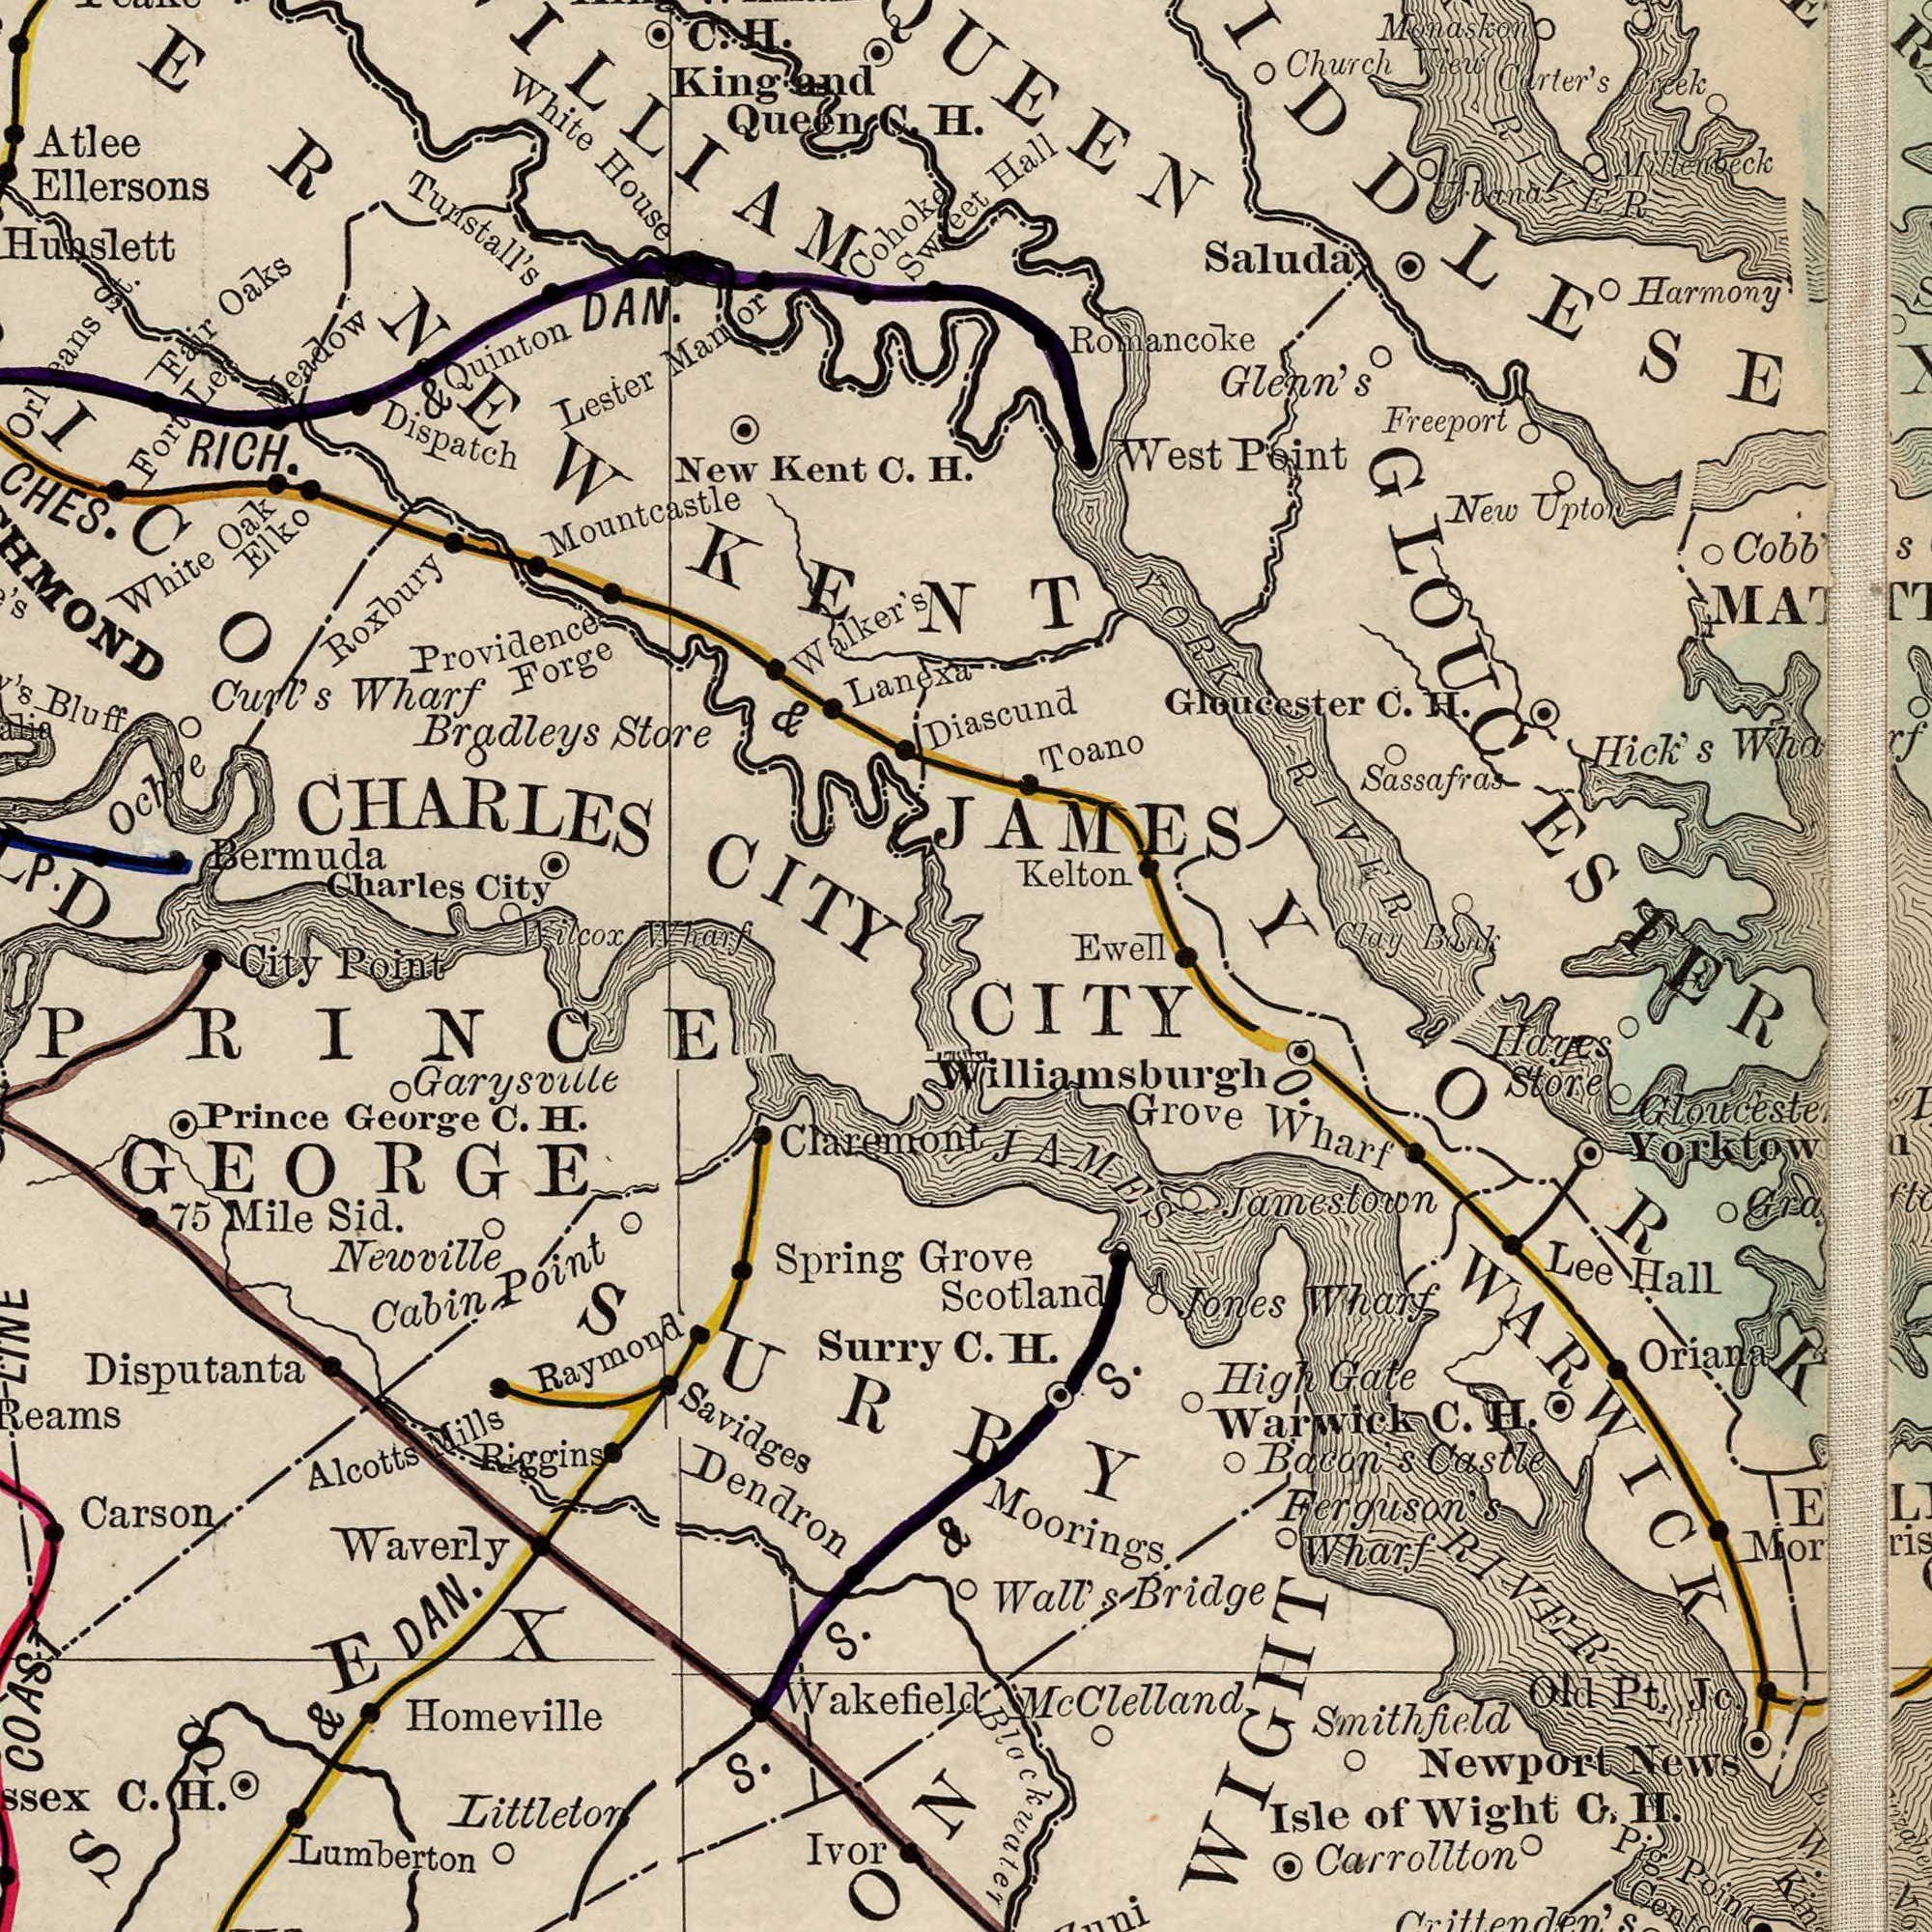What text is visible in the upper-left corner? Tunstall's Charles City Bermuda Providence Forge Atlee RICH. & DAN. White House Ellersons Mountcastle New Kent C. H. Bluff Ochre Fair Oāks Lester Manor Bradleys Store Wilcox Wharf Elko Walker's D Dispatch Curl's Wharf CHARLES CITY Lanexa White Oak Meadow Roxbury Quinton Sweet Fort Lee Cohoke King and Queen C. H eans St. City Point & C. H. ###ICO What text can you see in the bottom-right section? CITY C. H. Grove S. Carrollton Yorktown Grove Wharf Smithfield Jamestown Newport News Oriana Scotland Hayes Store Bacon's Castle High Gate Moorings. Wall's Bridge Jones Wharf Lee Hall Old Pt. Jc. Isle of Wight C. H. Warwick C. H. Ferguson's Wharf Blackwater Pig Point JAMES RIVER WiIlliamsburgh WARWICK McClelland Crittenden's WIGHT O. YORK What text appears in the top-right area of the image? Hall Romancoke Kelton JAMES Gloucester C. H. Monaskon Carter's Creek Harmony Saluda Sassafras Church View Hick's Wharf Freeport New Upton Cobb's Diascund Toano Glenn's West Point Ewell YORK RIVER Clay Bank Millebeck band GLOUCESTER RIVER What text can you see in the bottom-left section? Savidges Waverly Newville Homeville Dendron Claremont Carson Lumberton Prince George C. H. Surry Spring Raymond 75 Mile Sid. Littleton COAST C. H. & DAN. Ivor Garysvule Alcotts Mills Riggins Cabin Point S. S. & Disputanta PRINCE GEORGE Wakefiel #SSEX SURRY 